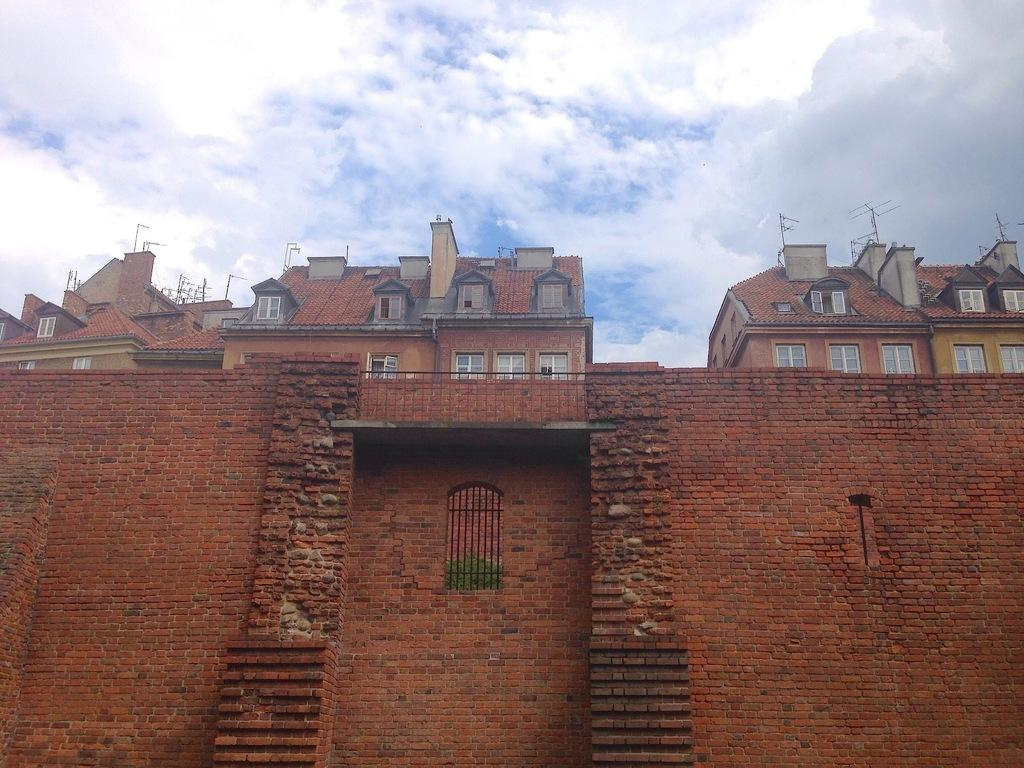What type of structure can be seen in the image? There is a wall in the image. What is the color of the wall? The wall is brick in color. What is visible above the wall in the image? There are buildings above the wall. What is the condition of the sky in the image? The sky is cloudy in the image. What type of powder is being used to clean the wall in the image? There is no indication in the image that any powder is being used to clean the wall. What type of oil is visible dripping from the buildings in the image? There is no oil visible dripping from the buildings in the image. 